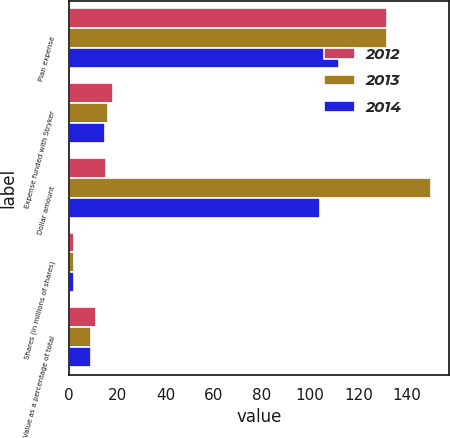Convert chart to OTSL. <chart><loc_0><loc_0><loc_500><loc_500><stacked_bar_chart><ecel><fcel>Plan expense<fcel>Expense funded with Stryker<fcel>Dollar amount<fcel>Shares (in millions of shares)<fcel>Value as a percentage of total<nl><fcel>2012<fcel>132<fcel>18<fcel>15.5<fcel>2.1<fcel>11<nl><fcel>2013<fcel>132<fcel>16<fcel>150<fcel>2<fcel>9<nl><fcel>2014<fcel>112<fcel>15<fcel>104<fcel>1.9<fcel>9<nl></chart> 